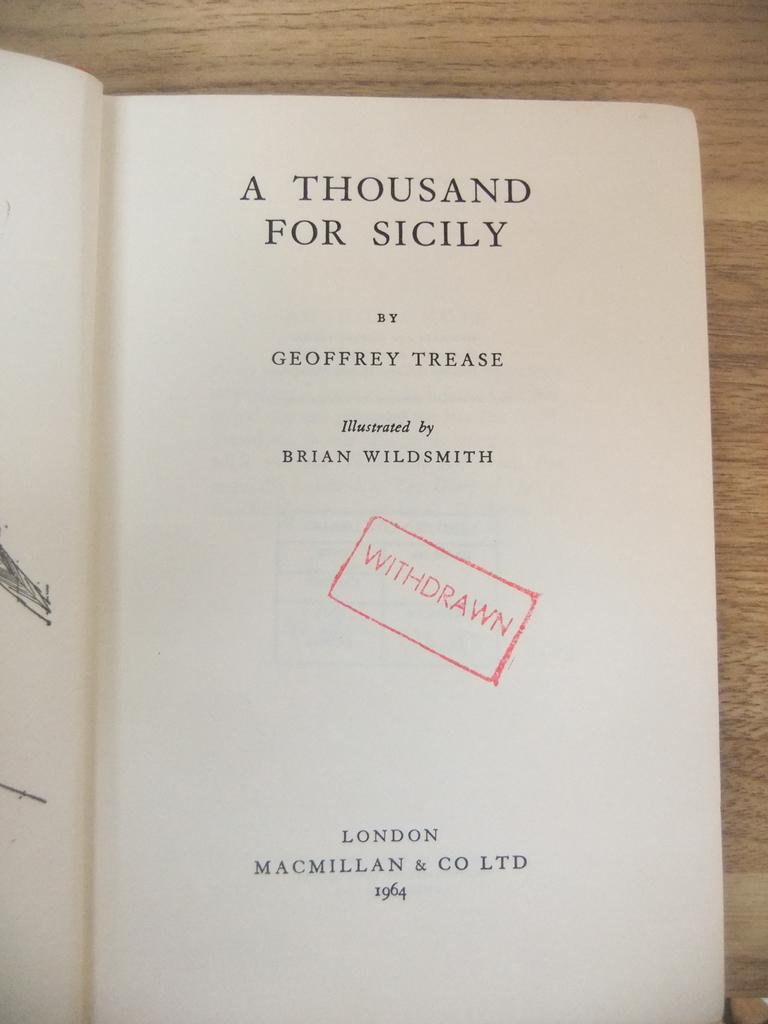<image>
Offer a succinct explanation of the picture presented. A book opened to the first page that is titled, A Thousand for Sicily. 